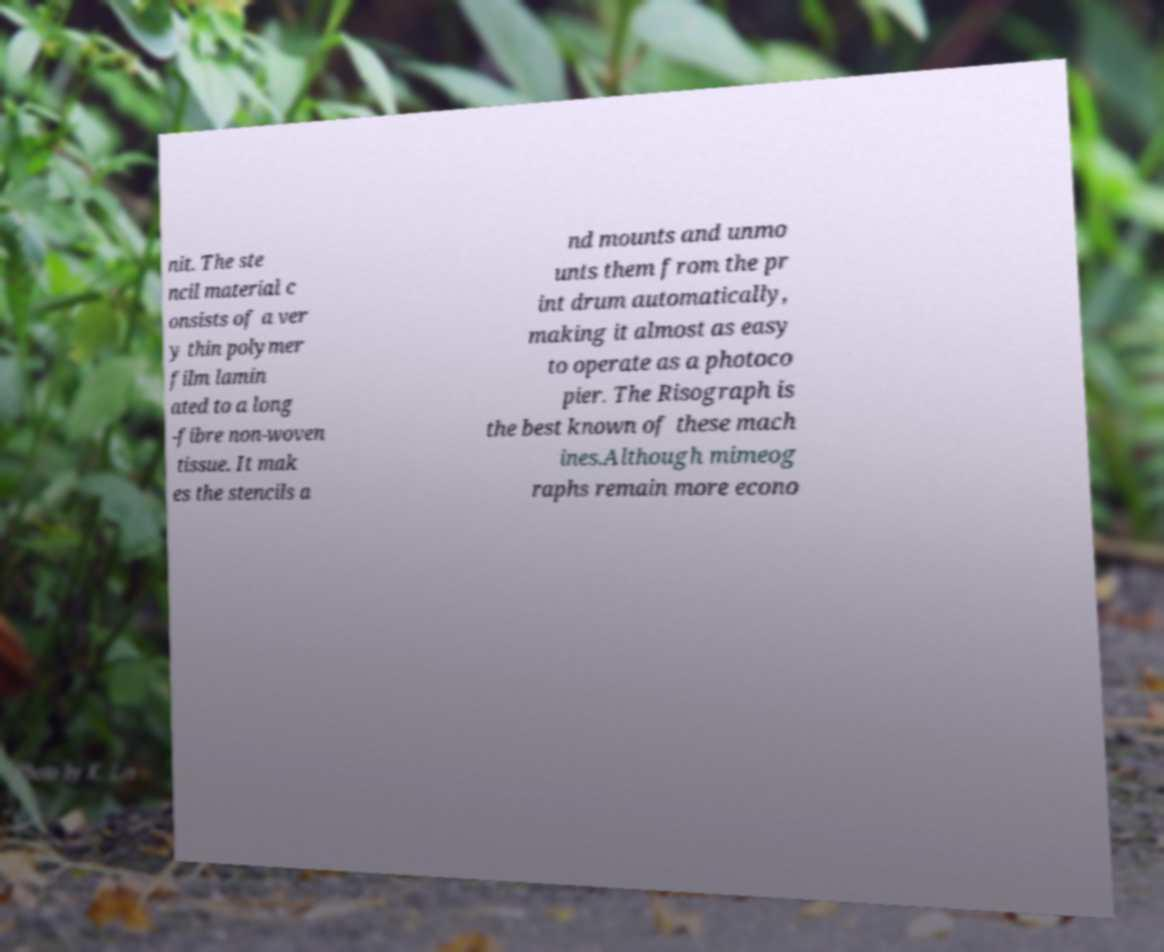Please identify and transcribe the text found in this image. nit. The ste ncil material c onsists of a ver y thin polymer film lamin ated to a long -fibre non-woven tissue. It mak es the stencils a nd mounts and unmo unts them from the pr int drum automatically, making it almost as easy to operate as a photoco pier. The Risograph is the best known of these mach ines.Although mimeog raphs remain more econo 